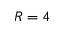<formula> <loc_0><loc_0><loc_500><loc_500>R = 4</formula> 